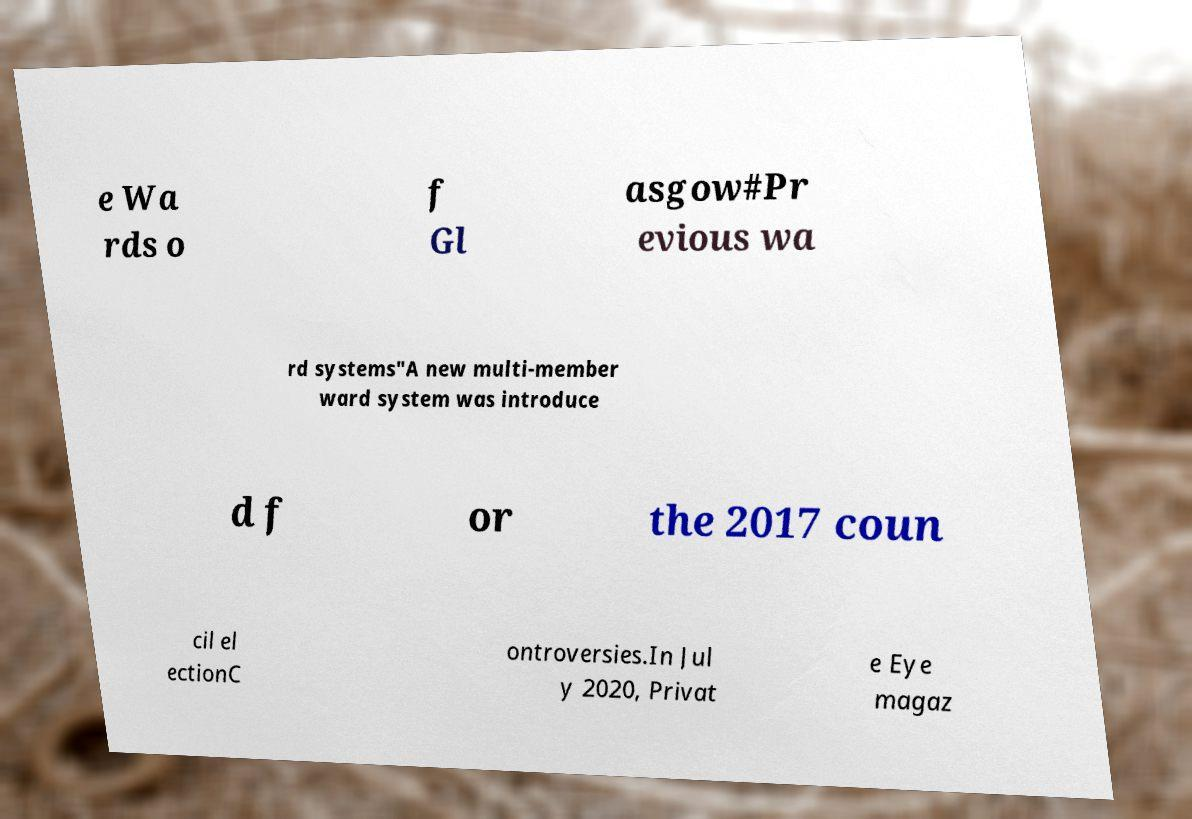For documentation purposes, I need the text within this image transcribed. Could you provide that? e Wa rds o f Gl asgow#Pr evious wa rd systems"A new multi-member ward system was introduce d f or the 2017 coun cil el ectionC ontroversies.In Jul y 2020, Privat e Eye magaz 